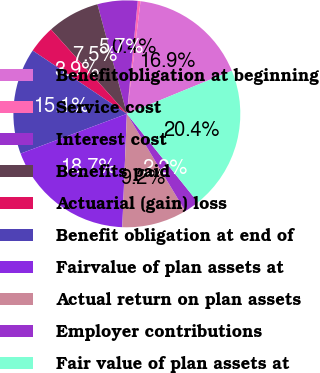<chart> <loc_0><loc_0><loc_500><loc_500><pie_chart><fcel>Benefitobligation at beginning<fcel>Service cost<fcel>Interest cost<fcel>Benefits paid<fcel>Actuarial (gain) loss<fcel>Benefit obligation at end of<fcel>Fairvalue of plan assets at<fcel>Actual return on plan assets<fcel>Employer contributions<fcel>Fair value of plan assets at<nl><fcel>16.88%<fcel>0.39%<fcel>5.71%<fcel>7.48%<fcel>3.93%<fcel>15.11%<fcel>18.66%<fcel>9.25%<fcel>2.16%<fcel>20.43%<nl></chart> 